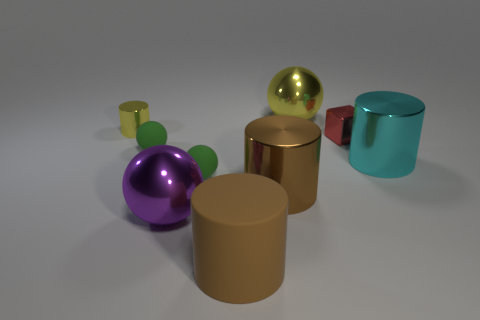Subtract all large cyan cylinders. How many cylinders are left? 3 Subtract all blue cylinders. How many green balls are left? 2 Subtract all yellow spheres. How many spheres are left? 3 Subtract all blocks. How many objects are left? 8 Add 1 big green things. How many objects exist? 10 Subtract 0 gray balls. How many objects are left? 9 Subtract all blue cubes. Subtract all purple spheres. How many cubes are left? 1 Subtract all big yellow rubber cylinders. Subtract all big cyan cylinders. How many objects are left? 8 Add 4 large purple things. How many large purple things are left? 5 Add 2 small green objects. How many small green objects exist? 4 